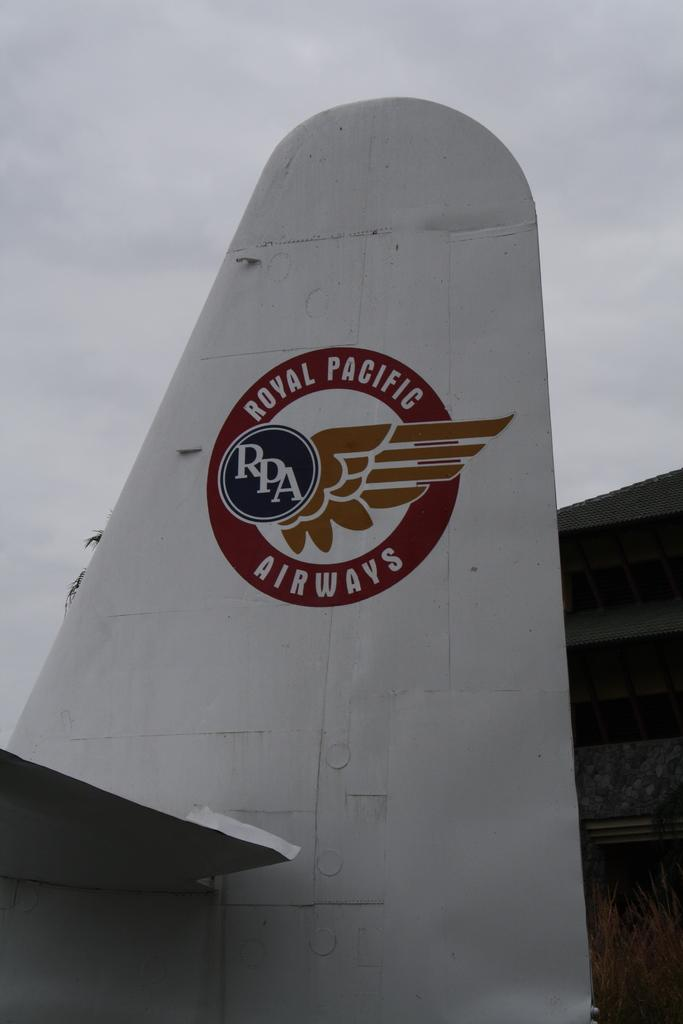What is the main subject of the image? The main subject of the image is a plane's wing. Where is the plane's wing located in relation to other objects in the image? The plane's wing is near a shed in the image. What company might be associated with the plane's wing, based on the logo in the image? The company logo in the image can help identify the company associated with the plane's wing. What can be seen in the sky in the image? The sky is visible in the image, and clouds are present. What type of vegetation is in the image? There is a tree in the image. What type of soda is being poured from the plane's wing in the image? There is no soda present in the image, and the plane's wing is not pouring any liquid. What type of spacecraft can be seen in the image? There is no spacecraft present in the image; it features a plane's wing. 